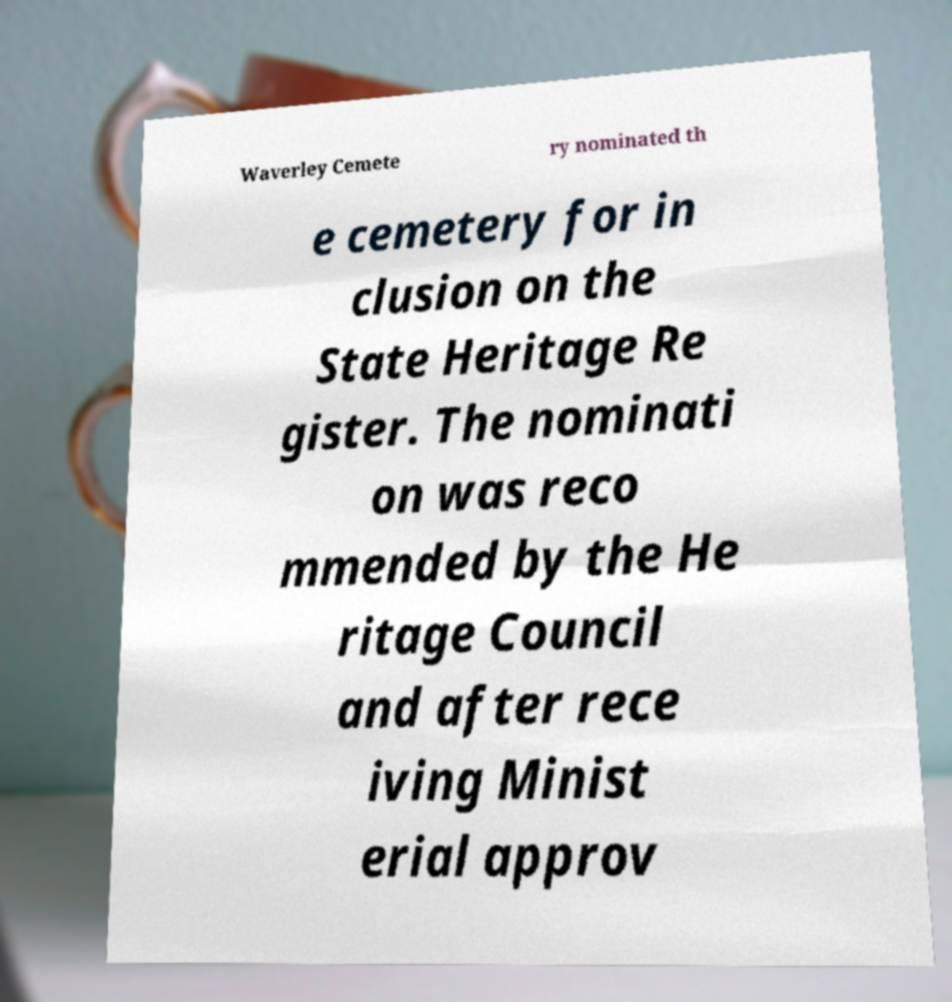There's text embedded in this image that I need extracted. Can you transcribe it verbatim? Waverley Cemete ry nominated th e cemetery for in clusion on the State Heritage Re gister. The nominati on was reco mmended by the He ritage Council and after rece iving Minist erial approv 